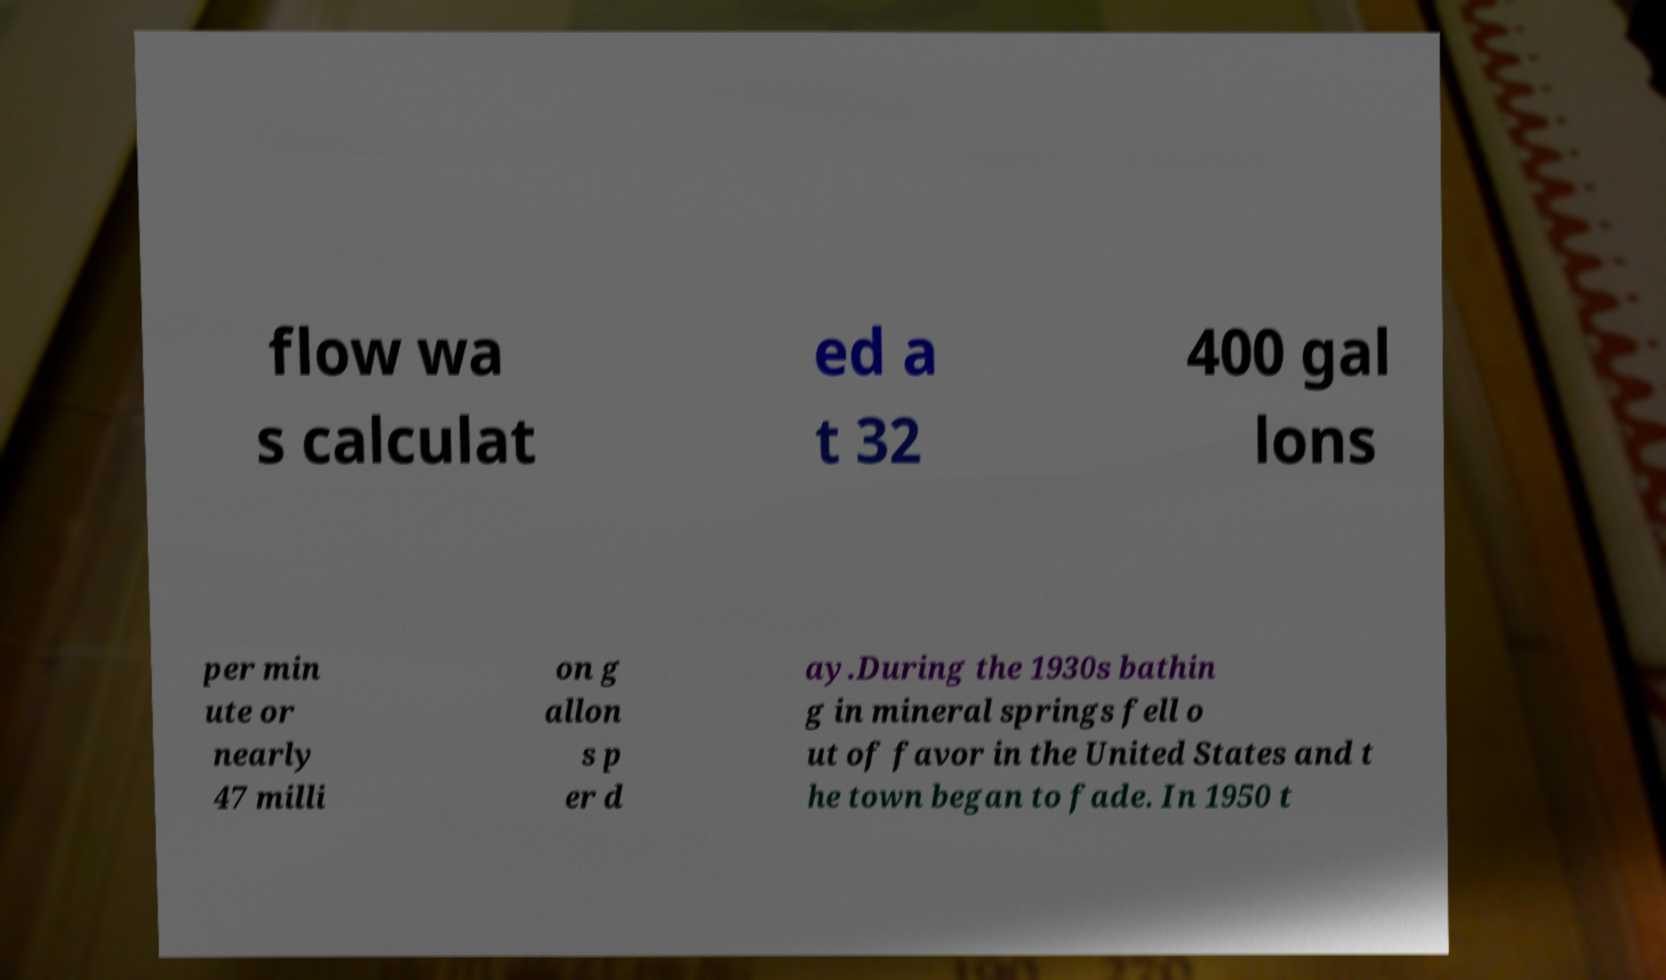Please identify and transcribe the text found in this image. flow wa s calculat ed a t 32 400 gal lons per min ute or nearly 47 milli on g allon s p er d ay.During the 1930s bathin g in mineral springs fell o ut of favor in the United States and t he town began to fade. In 1950 t 